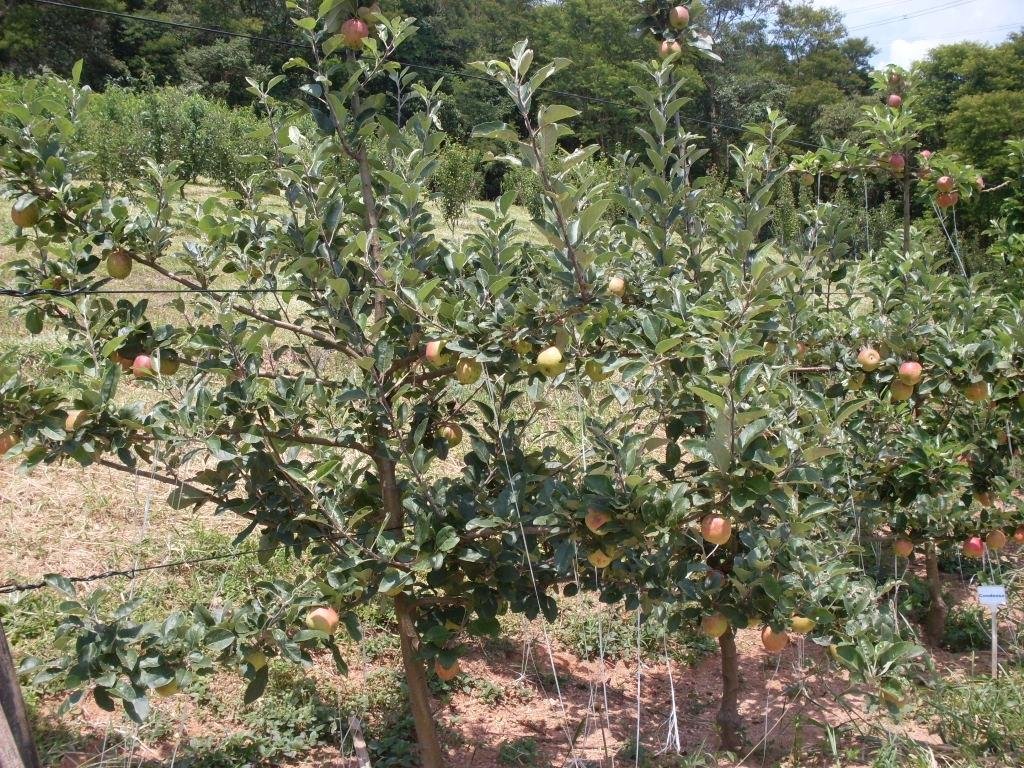What type of trees can be seen in the image? There are trees with fruits in the image. Can you describe the trees in the background of the image? There are trees in the background of the image. What can be seen in the sky in the background of the image? The sky is visible in the background of the image. What type of steel is used to make the jam visible in the image? There is no jam or steel present in the image. 